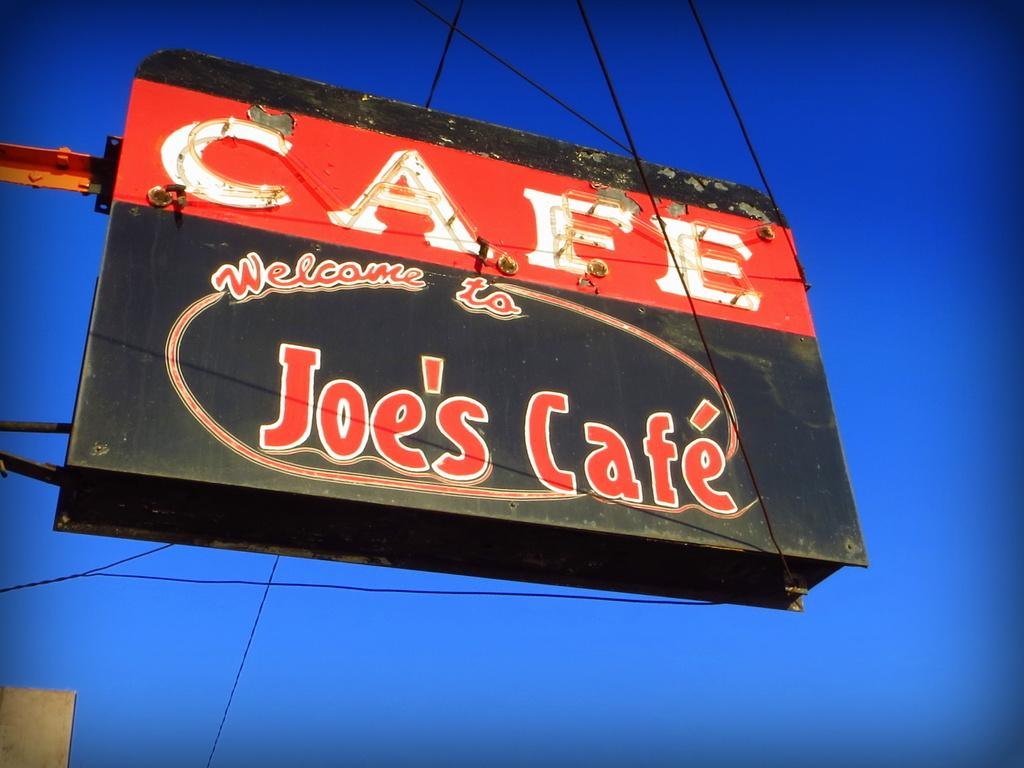Provide a one-sentence caption for the provided image. The Cafe is called Joe's Cafe and is welcoming you. 